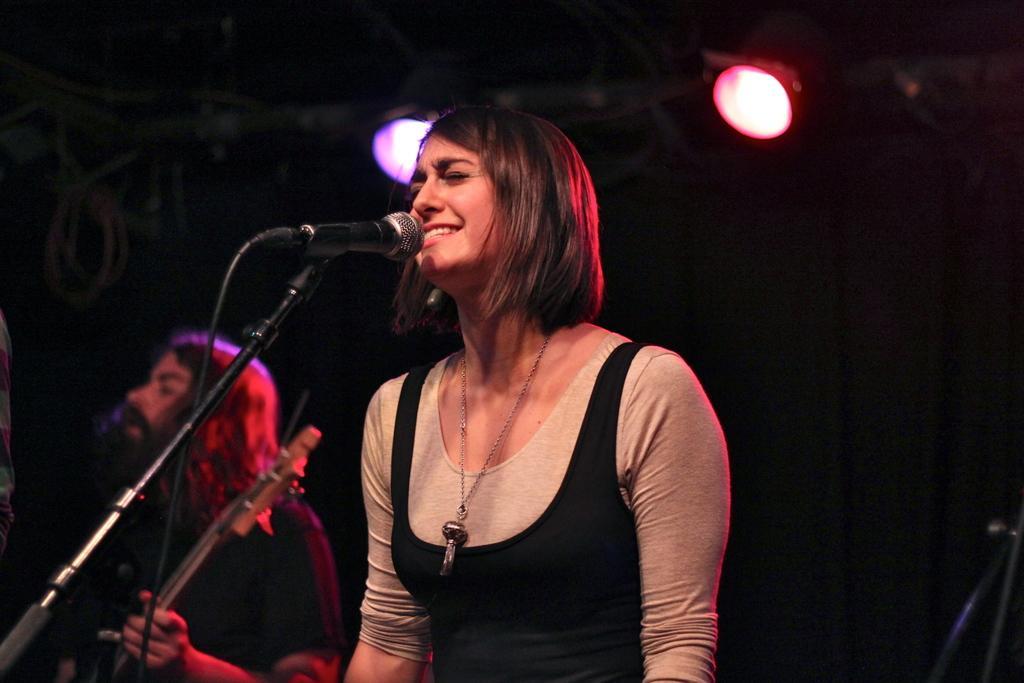In one or two sentences, can you explain what this image depicts? There is a woman in black color jacket, standing in front of a mic which is attached to the stand, and singing, near another person, who is singing, holding and playing guitar. In the background, there are lights attached to the roof. And the background is dark in color. 